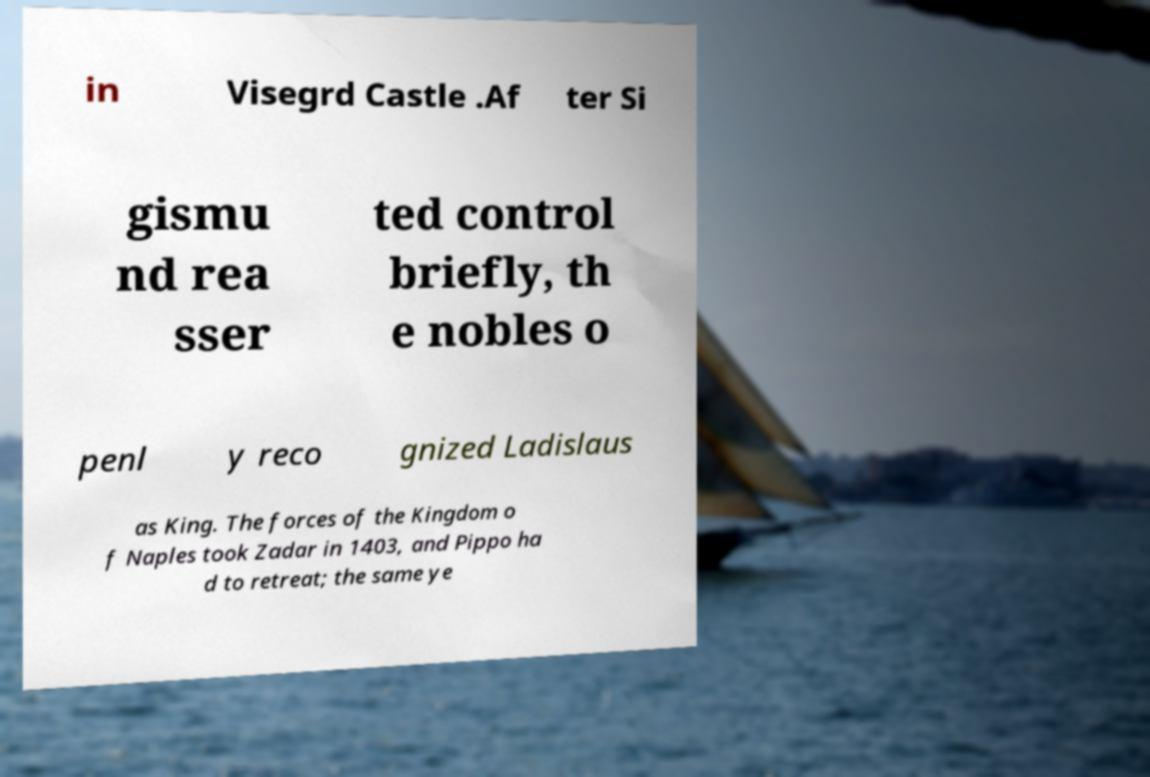Can you read and provide the text displayed in the image?This photo seems to have some interesting text. Can you extract and type it out for me? in Visegrd Castle .Af ter Si gismu nd rea sser ted control briefly, th e nobles o penl y reco gnized Ladislaus as King. The forces of the Kingdom o f Naples took Zadar in 1403, and Pippo ha d to retreat; the same ye 